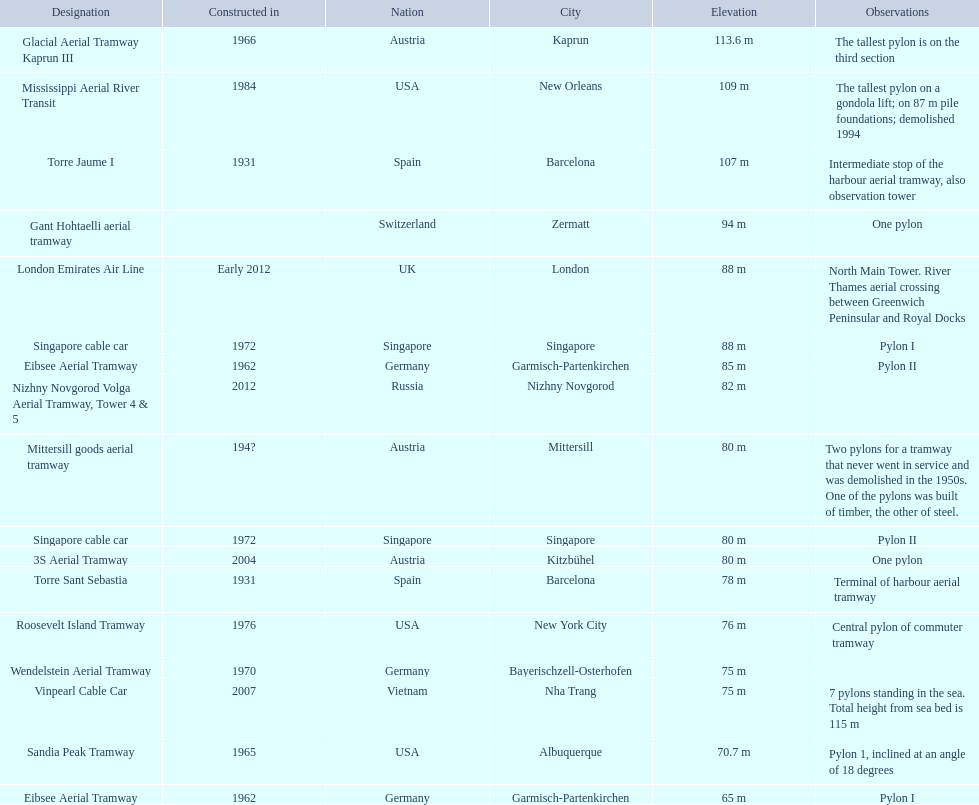What is the pylon with the least height listed here? Eibsee Aerial Tramway. 